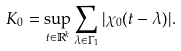Convert formula to latex. <formula><loc_0><loc_0><loc_500><loc_500>K _ { 0 } = \sup _ { t \in \mathbb { R } ^ { k } } \sum _ { \lambda \in \Gamma _ { 1 } } | \chi _ { 0 } ( t - \lambda ) | .</formula> 